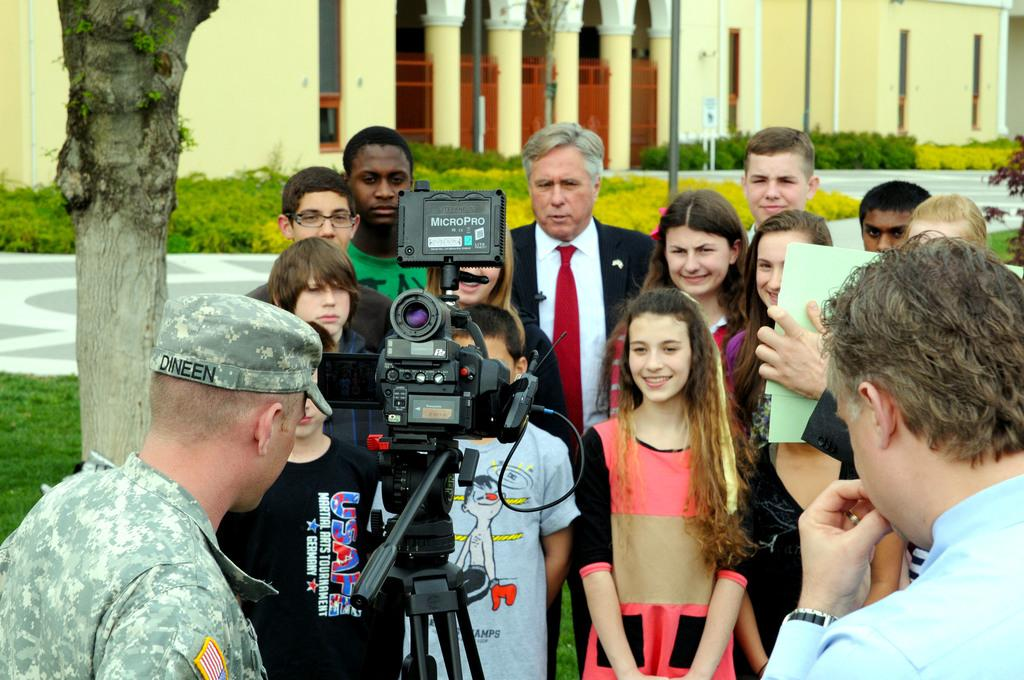How many people are in the image? There is a group of people in the image, but the exact number cannot be determined from the provided facts. What object is visible in the image that is typically used for capturing images? There is a camera in the image. What can be seen in the background of the image? There is a building, plants, a tree trunk, and some objects in the background of the image. What type of plate is being used to serve the oranges in the image? There is no plate or oranges present in the image. What advice is the coach giving to the group of people in the image? There is no coach or advice-giving activity depicted in the image. 